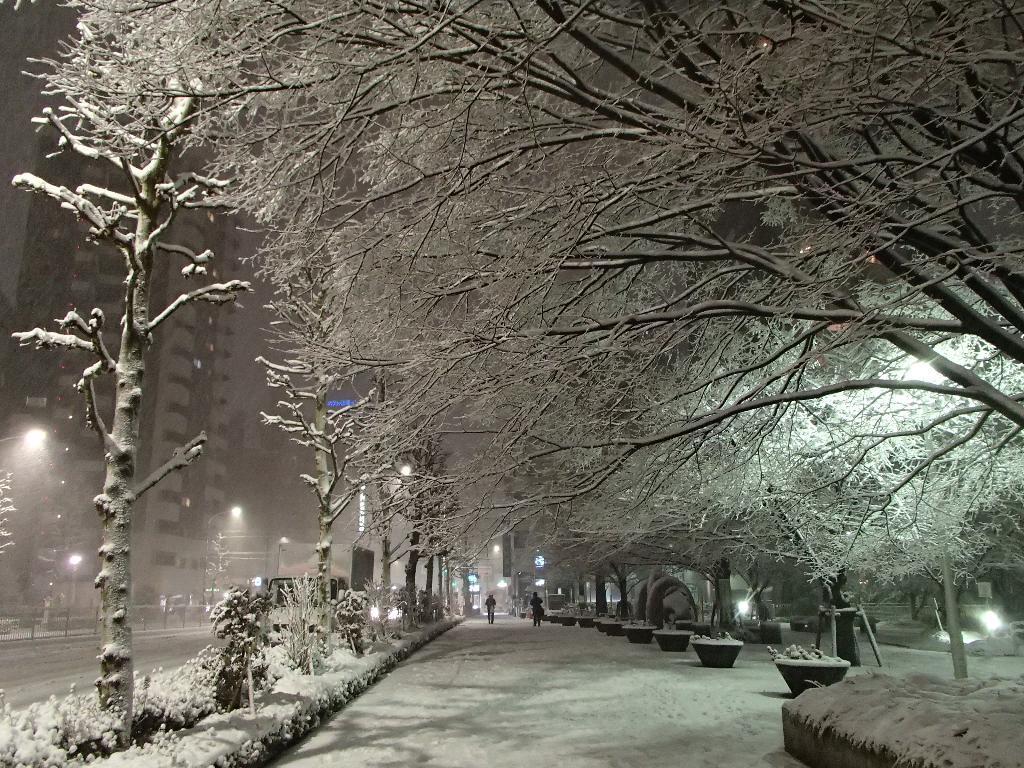Could you give a brief overview of what you see in this image? In this picture there are trees and buildings on the right and left side of the image and there are people in the center of the image, there is snow at the bottom side of the image and on trees, it seems to be the picture is captured during night time. 